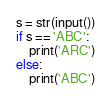<code> <loc_0><loc_0><loc_500><loc_500><_Python_>s = str(input())
if s == 'ABC':
    print('ARC')
else:
    print('ABC')</code> 